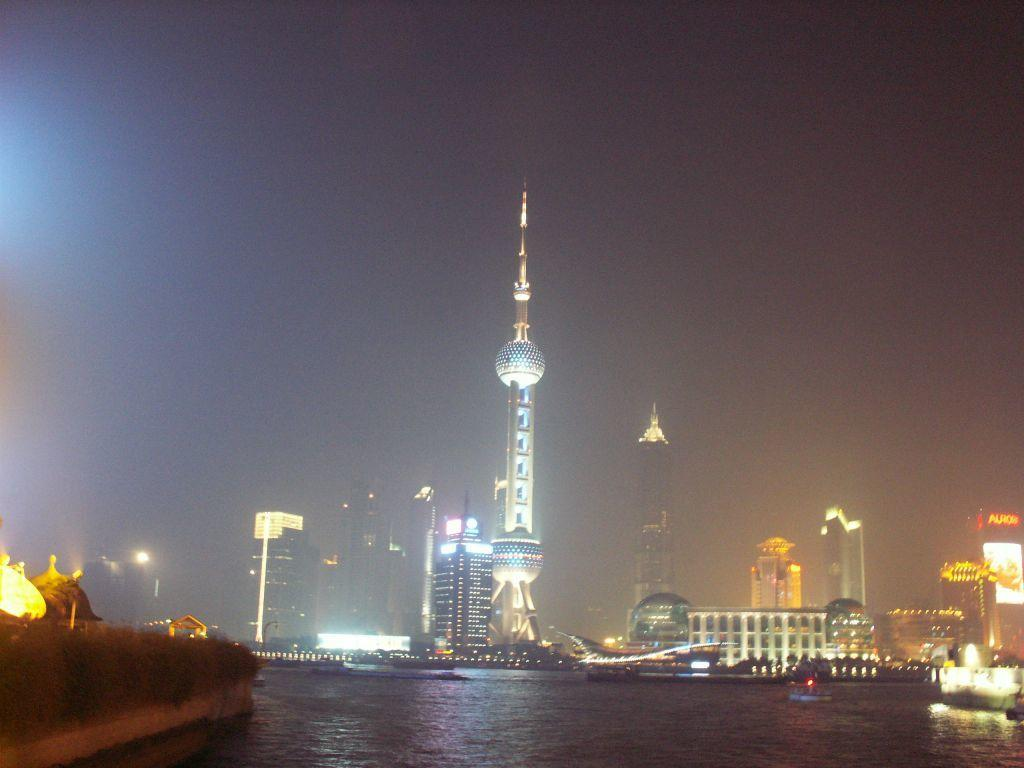What type of structures can be seen in the image? There are buildings and towers in the image. What additional features are present in the image? There are lights, plants, boats, and water visible in the image. What can be seen in the background of the image? The sky is visible in the background of the image. What type of silk hat is the boat wearing in the image? There are no boats wearing hats in the image; boats do not wear hats. 